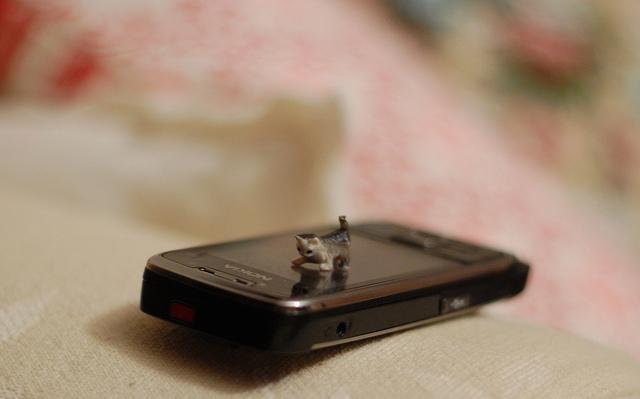How many people are there wearing black shirts?
Give a very brief answer. 0. 